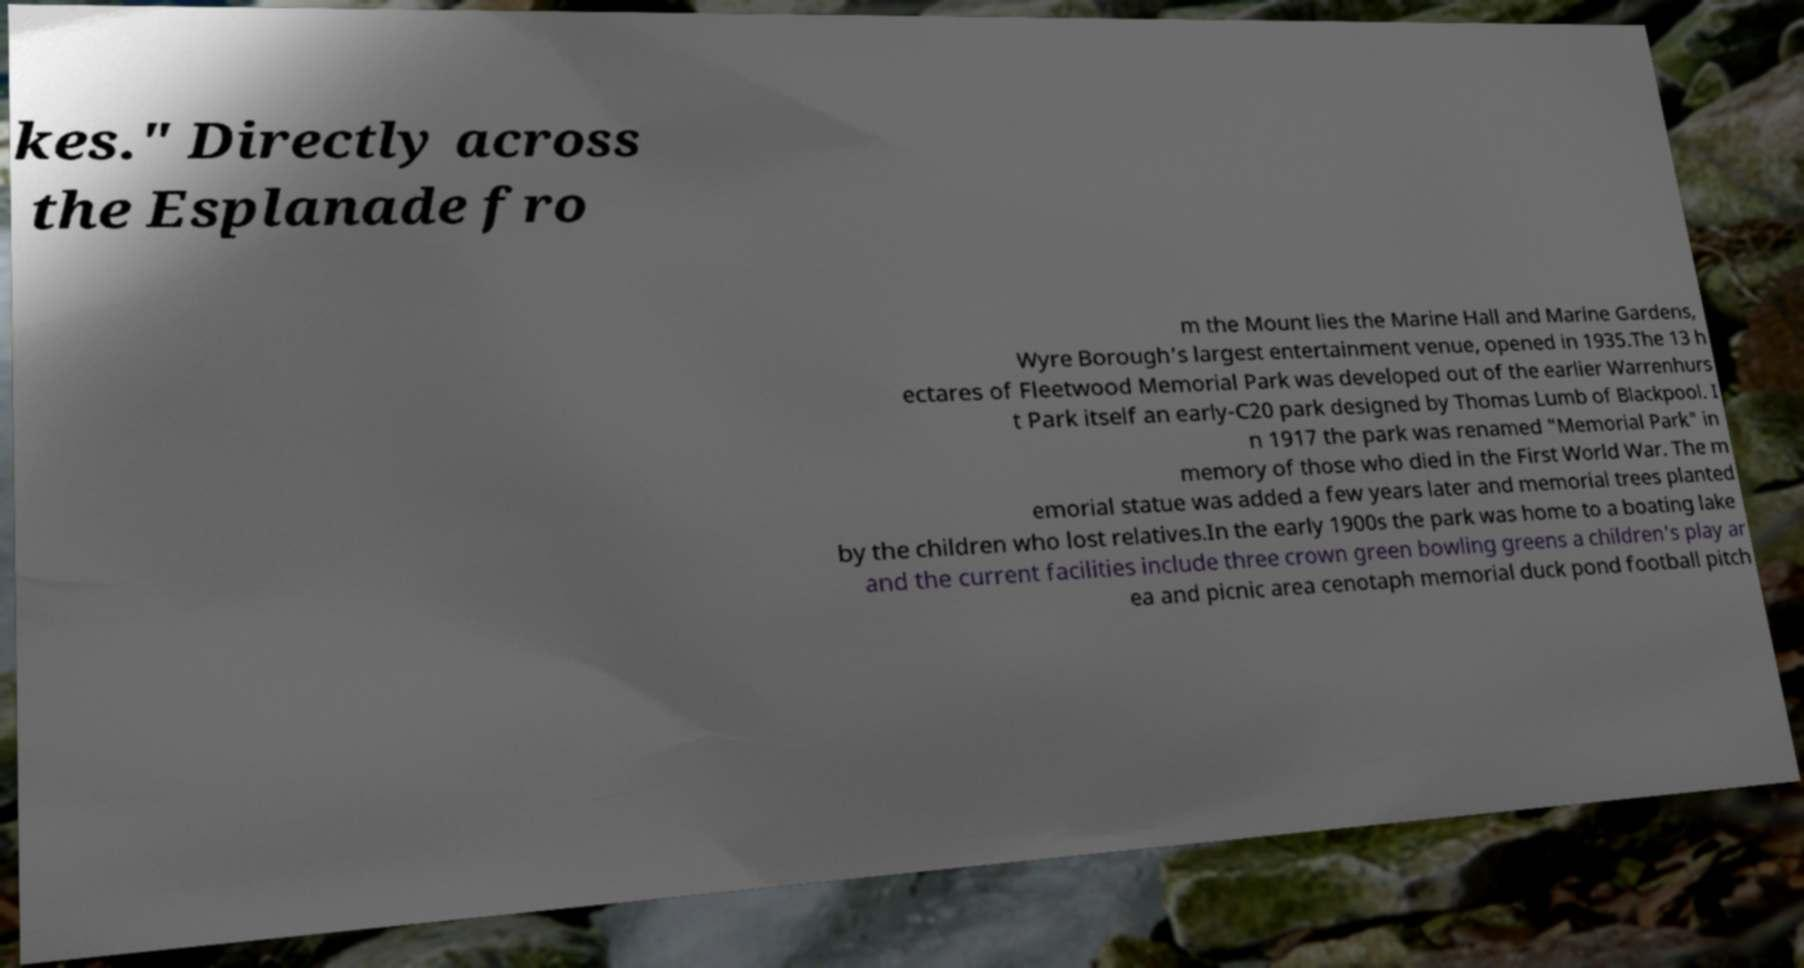What messages or text are displayed in this image? I need them in a readable, typed format. kes." Directly across the Esplanade fro m the Mount lies the Marine Hall and Marine Gardens, Wyre Borough's largest entertainment venue, opened in 1935.The 13 h ectares of Fleetwood Memorial Park was developed out of the earlier Warrenhurs t Park itself an early-C20 park designed by Thomas Lumb of Blackpool. I n 1917 the park was renamed "Memorial Park" in memory of those who died in the First World War. The m emorial statue was added a few years later and memorial trees planted by the children who lost relatives.In the early 1900s the park was home to a boating lake and the current facilities include three crown green bowling greens a children's play ar ea and picnic area cenotaph memorial duck pond football pitch 